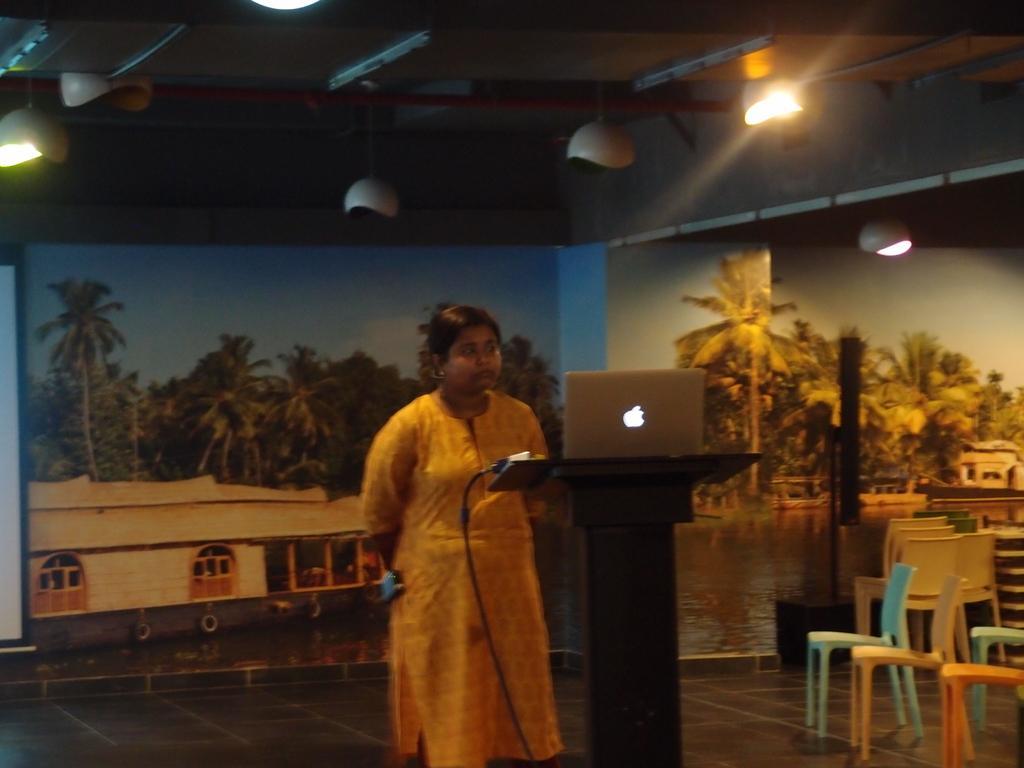In one or two sentences, can you explain what this image depicts? In this image, In the middle there is a table which is in black color on that table there is a laptop which is in white color, There is a girl standing behind the table, In the right side there are some chairs which are in white color, In the background there is a blue color poster on that poster there are some green color trees and there is a white color building, In the top there are some lights in which are in white color. 